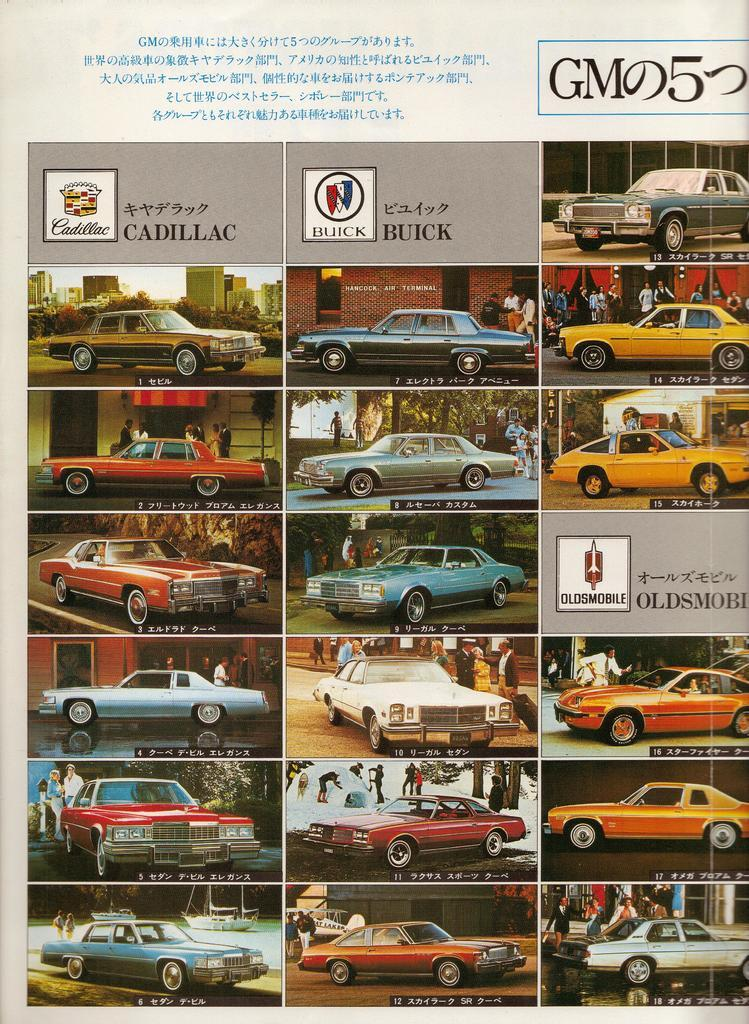What is depicted on the paper in the image? There is a collage of pictures on the paper. What types of objects or subjects are included in the collage? The pictures contain cars and people. Is there any text present on the paper? Yes, there is text on the paper. What color is the zipper on the hour in the image? There is no zipper or hour present in the image; it features a collage of pictures with cars and people, along with text. 